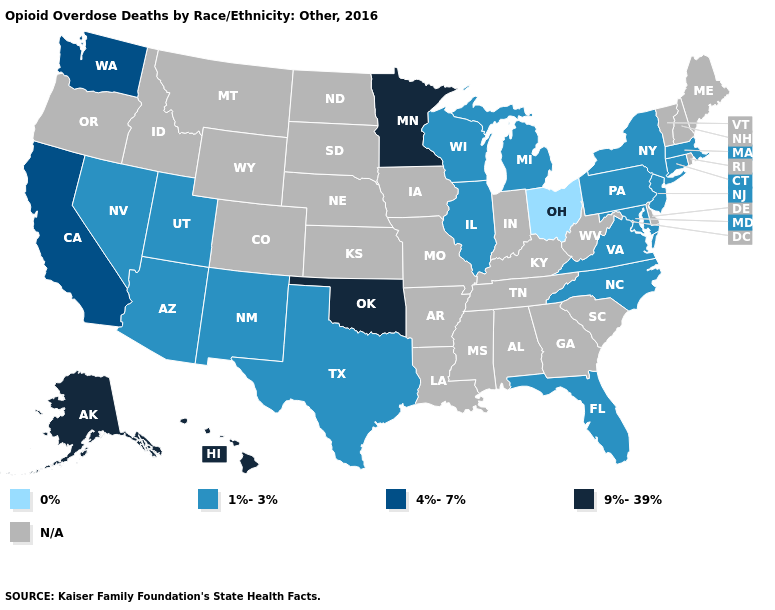What is the highest value in the Northeast ?
Quick response, please. 1%-3%. Does the first symbol in the legend represent the smallest category?
Keep it brief. Yes. What is the lowest value in the South?
Quick response, please. 1%-3%. Does the first symbol in the legend represent the smallest category?
Answer briefly. Yes. What is the value of North Dakota?
Give a very brief answer. N/A. Does Washington have the lowest value in the West?
Answer briefly. No. Name the states that have a value in the range 0%?
Keep it brief. Ohio. Name the states that have a value in the range 4%-7%?
Give a very brief answer. California, Washington. Which states hav the highest value in the Northeast?
Keep it brief. Connecticut, Massachusetts, New Jersey, New York, Pennsylvania. Does New Mexico have the lowest value in the USA?
Give a very brief answer. No. Among the states that border Maryland , which have the highest value?
Keep it brief. Pennsylvania, Virginia. What is the value of Montana?
Write a very short answer. N/A. Does the map have missing data?
Answer briefly. Yes. 